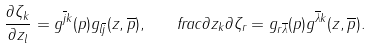<formula> <loc_0><loc_0><loc_500><loc_500>\frac { \partial \zeta _ { k } } { \partial z _ { l } } = g ^ { \overline { j } k } ( p ) g _ { l \overline { j } } ( z , \overline { p } ) , \quad f r a c { \partial z _ { k } } { \partial \zeta _ { r } } = g _ { r \overline { \lambda } } ( p ) g ^ { \overline { \lambda } k } ( z , \overline { p } ) .</formula> 